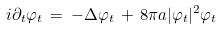Convert formula to latex. <formula><loc_0><loc_0><loc_500><loc_500>i \partial _ { t } \varphi _ { t } \, = \, - \Delta \varphi _ { t } \, + \, 8 \pi a | \varphi _ { t } | ^ { 2 } \varphi _ { t }</formula> 